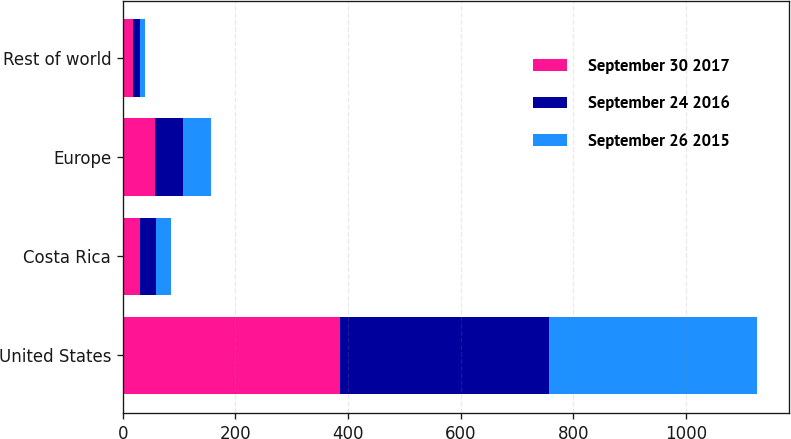Convert chart to OTSL. <chart><loc_0><loc_0><loc_500><loc_500><stacked_bar_chart><ecel><fcel>United States<fcel>Costa Rica<fcel>Europe<fcel>Rest of world<nl><fcel>September 30 2017<fcel>386.5<fcel>30.1<fcel>57.1<fcel>17.5<nl><fcel>September 24 2016<fcel>370.7<fcel>28.1<fcel>49.2<fcel>12.2<nl><fcel>September 26 2015<fcel>369.1<fcel>27.7<fcel>50.8<fcel>9.5<nl></chart> 